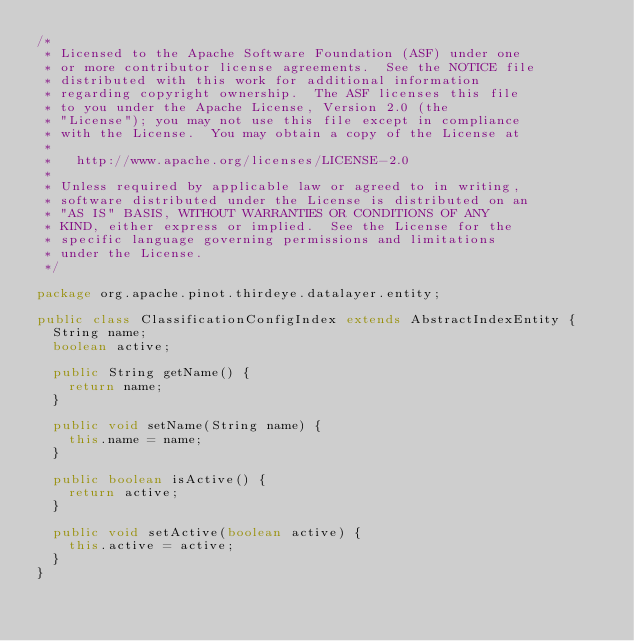Convert code to text. <code><loc_0><loc_0><loc_500><loc_500><_Java_>/*
 * Licensed to the Apache Software Foundation (ASF) under one
 * or more contributor license agreements.  See the NOTICE file
 * distributed with this work for additional information
 * regarding copyright ownership.  The ASF licenses this file
 * to you under the Apache License, Version 2.0 (the
 * "License"); you may not use this file except in compliance
 * with the License.  You may obtain a copy of the License at
 *
 *   http://www.apache.org/licenses/LICENSE-2.0
 *
 * Unless required by applicable law or agreed to in writing,
 * software distributed under the License is distributed on an
 * "AS IS" BASIS, WITHOUT WARRANTIES OR CONDITIONS OF ANY
 * KIND, either express or implied.  See the License for the
 * specific language governing permissions and limitations
 * under the License.
 */

package org.apache.pinot.thirdeye.datalayer.entity;

public class ClassificationConfigIndex extends AbstractIndexEntity {
  String name;
  boolean active;

  public String getName() {
    return name;
  }

  public void setName(String name) {
    this.name = name;
  }

  public boolean isActive() {
    return active;
  }

  public void setActive(boolean active) {
    this.active = active;
  }
}
</code> 